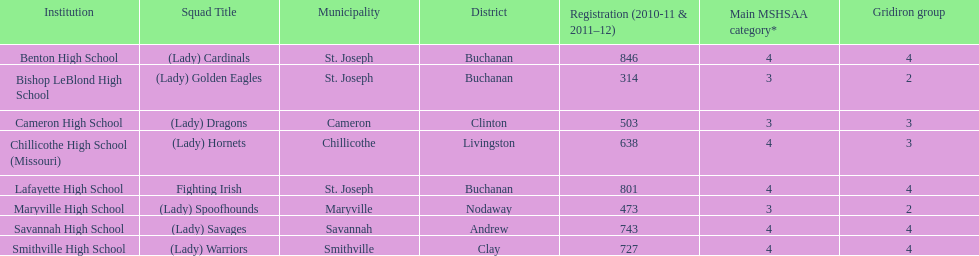Parse the full table. {'header': ['Institution', 'Squad Title', 'Municipality', 'District', 'Registration (2010-11 & 2011–12)', 'Main MSHSAA category*', 'Gridiron group'], 'rows': [['Benton High School', '(Lady) Cardinals', 'St. Joseph', 'Buchanan', '846', '4', '4'], ['Bishop LeBlond High School', '(Lady) Golden Eagles', 'St. Joseph', 'Buchanan', '314', '3', '2'], ['Cameron High School', '(Lady) Dragons', 'Cameron', 'Clinton', '503', '3', '3'], ['Chillicothe High School (Missouri)', '(Lady) Hornets', 'Chillicothe', 'Livingston', '638', '4', '3'], ['Lafayette High School', 'Fighting Irish', 'St. Joseph', 'Buchanan', '801', '4', '4'], ['Maryville High School', '(Lady) Spoofhounds', 'Maryville', 'Nodaway', '473', '3', '2'], ['Savannah High School', '(Lady) Savages', 'Savannah', 'Andrew', '743', '4', '4'], ['Smithville High School', '(Lady) Warriors', 'Smithville', 'Clay', '727', '4', '4']]} What schools are located in st. joseph? Benton High School, Bishop LeBlond High School, Lafayette High School. Which st. joseph schools have more then 800 enrollment  for 2010-11 7 2011-12? Benton High School, Lafayette High School. What is the name of the st. joseph school with 800 or more enrollment's team names is a not a (lady)? Lafayette High School. 